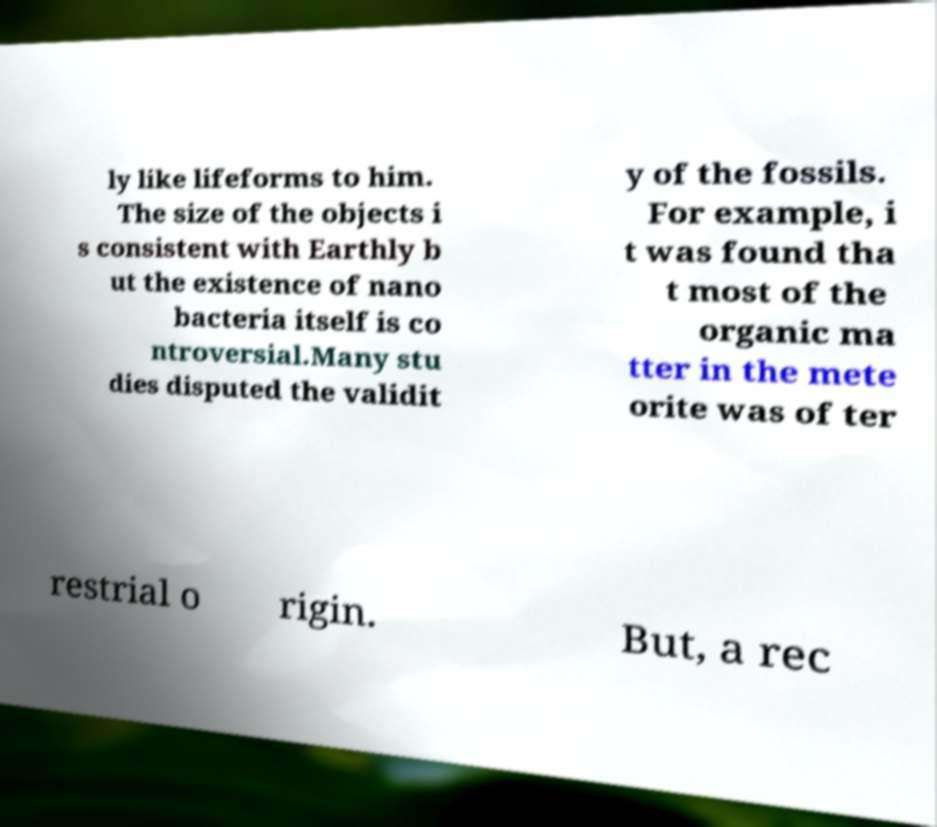There's text embedded in this image that I need extracted. Can you transcribe it verbatim? ly like lifeforms to him. The size of the objects i s consistent with Earthly b ut the existence of nano bacteria itself is co ntroversial.Many stu dies disputed the validit y of the fossils. For example, i t was found tha t most of the organic ma tter in the mete orite was of ter restrial o rigin. But, a rec 